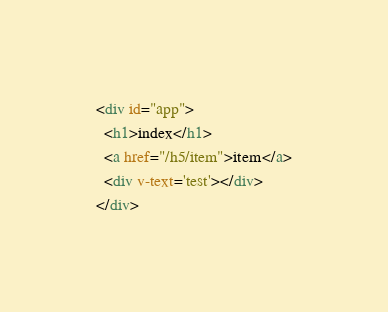Convert code to text. <code><loc_0><loc_0><loc_500><loc_500><_HTML_><div id="app">
  <h1>index</h1>
  <a href="/h5/item">item</a>
  <div v-text='test'></div>
</div></code> 